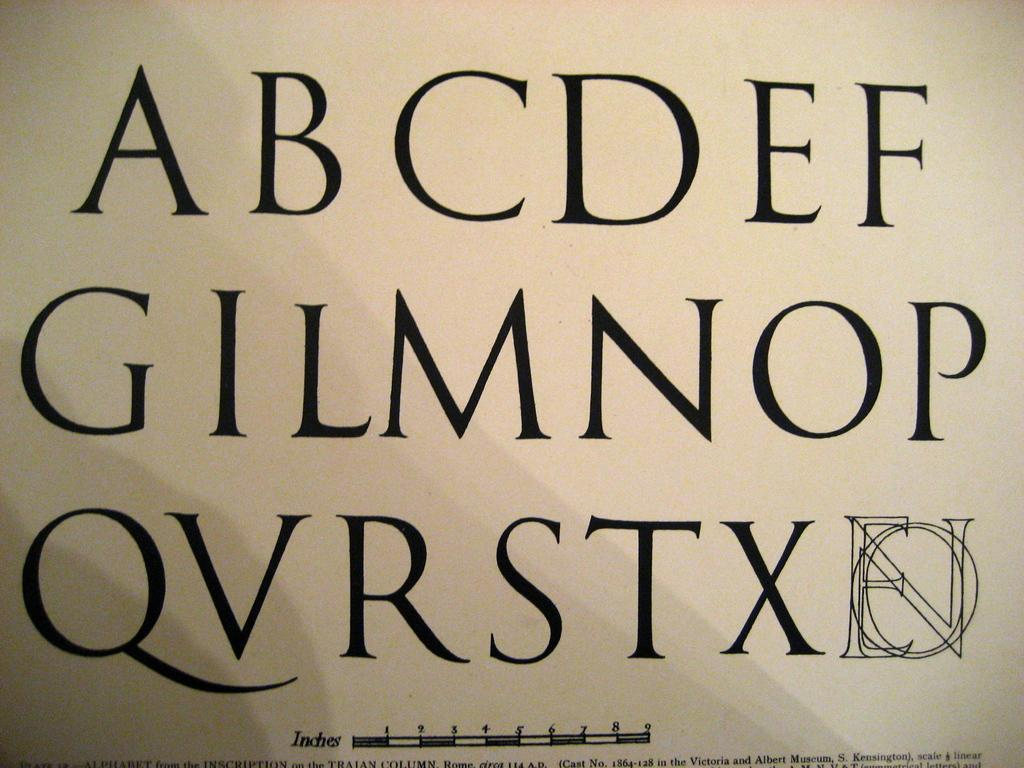<image>
Give a short and clear explanation of the subsequent image. Lettering ABCDEFGILMNOPQVRSTXEON as well as an inches measurement 